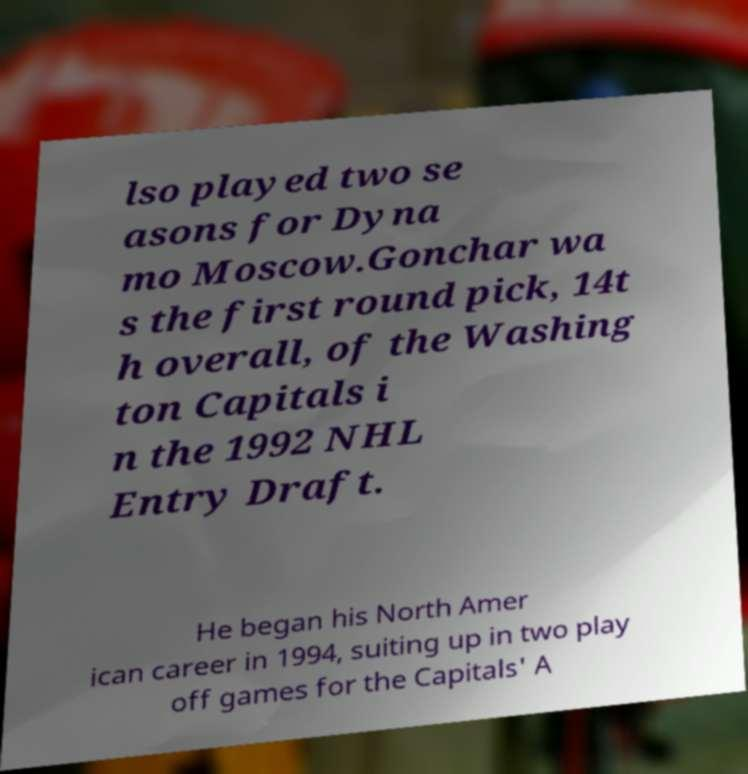Please identify and transcribe the text found in this image. lso played two se asons for Dyna mo Moscow.Gonchar wa s the first round pick, 14t h overall, of the Washing ton Capitals i n the 1992 NHL Entry Draft. He began his North Amer ican career in 1994, suiting up in two play off games for the Capitals' A 